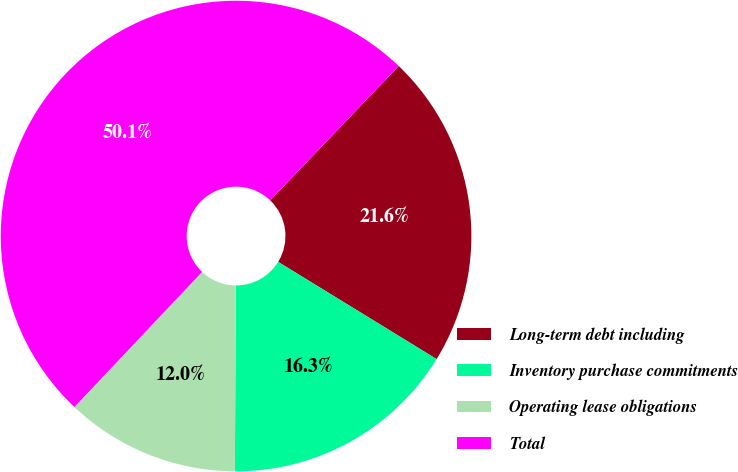<chart> <loc_0><loc_0><loc_500><loc_500><pie_chart><fcel>Long-term debt including<fcel>Inventory purchase commitments<fcel>Operating lease obligations<fcel>Total<nl><fcel>21.61%<fcel>16.32%<fcel>11.97%<fcel>50.09%<nl></chart> 